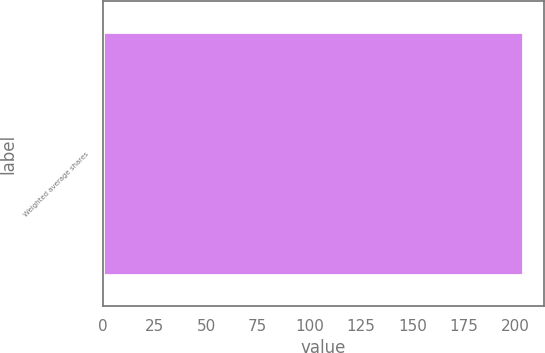Convert chart to OTSL. <chart><loc_0><loc_0><loc_500><loc_500><bar_chart><fcel>Weighted average shares<nl><fcel>203.7<nl></chart> 